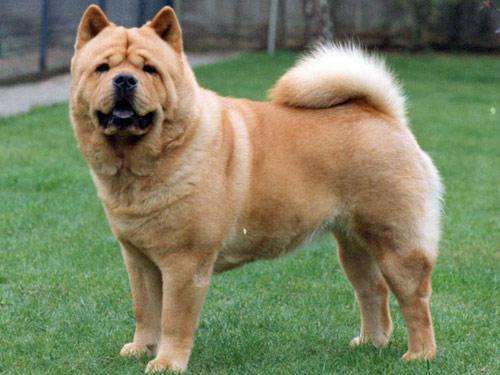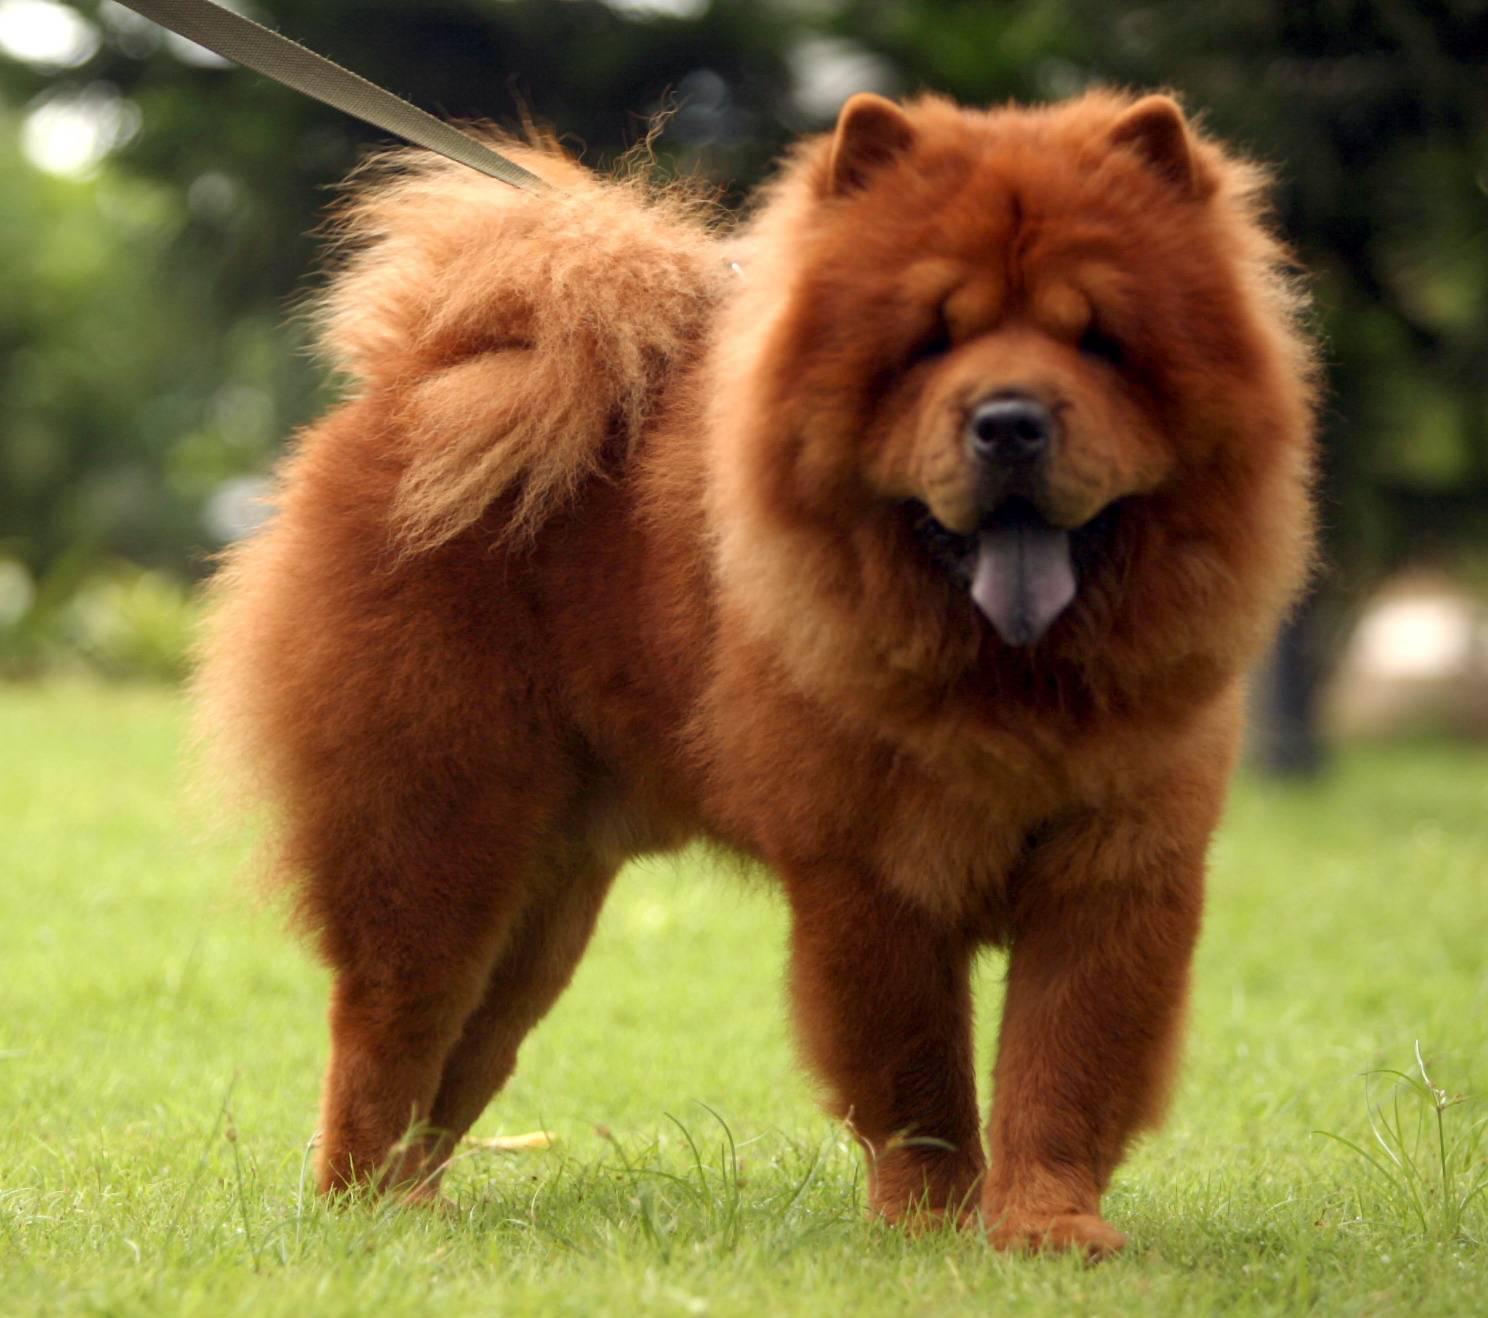The first image is the image on the left, the second image is the image on the right. Examine the images to the left and right. Is the description "The dog in the image on the right has its mouth open" accurate? Answer yes or no. Yes. 